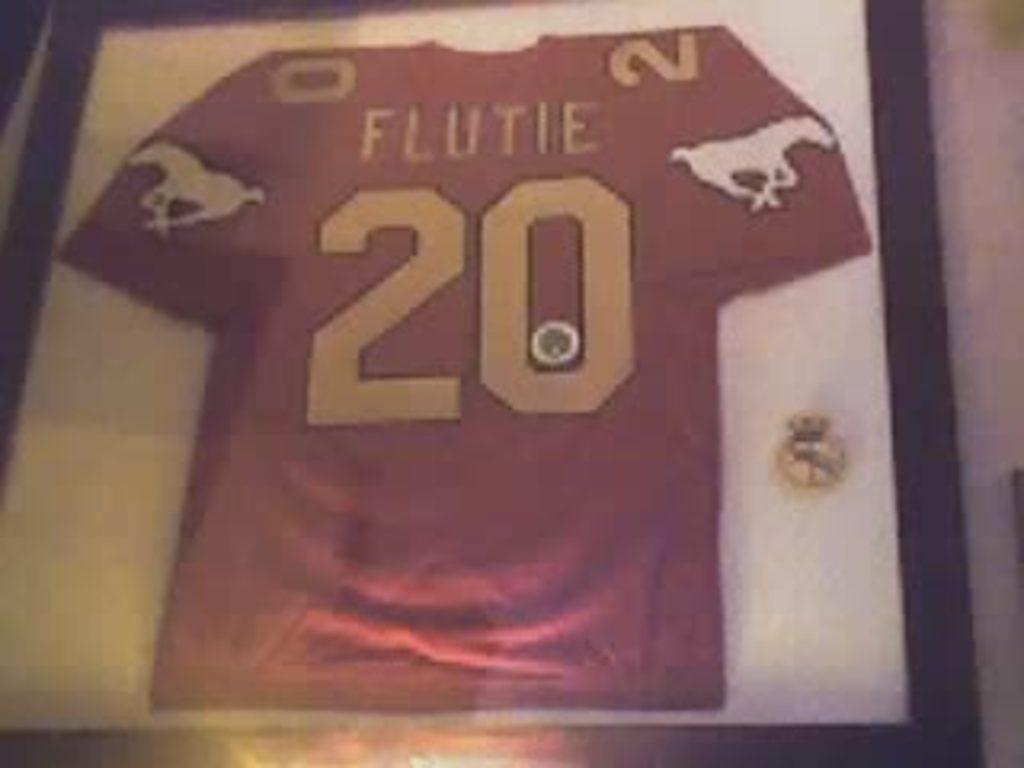What is the number written on this shirt?
Provide a succinct answer. 20. What is the players name on the jersey?
Provide a short and direct response. Flutie. 